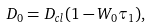Convert formula to latex. <formula><loc_0><loc_0><loc_500><loc_500>D _ { 0 } = D _ { c l } ( 1 - W _ { 0 } \tau _ { 1 } ) ,</formula> 